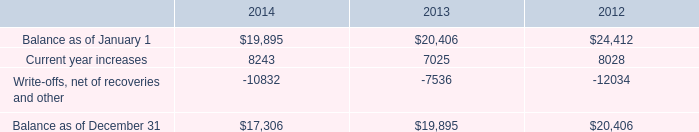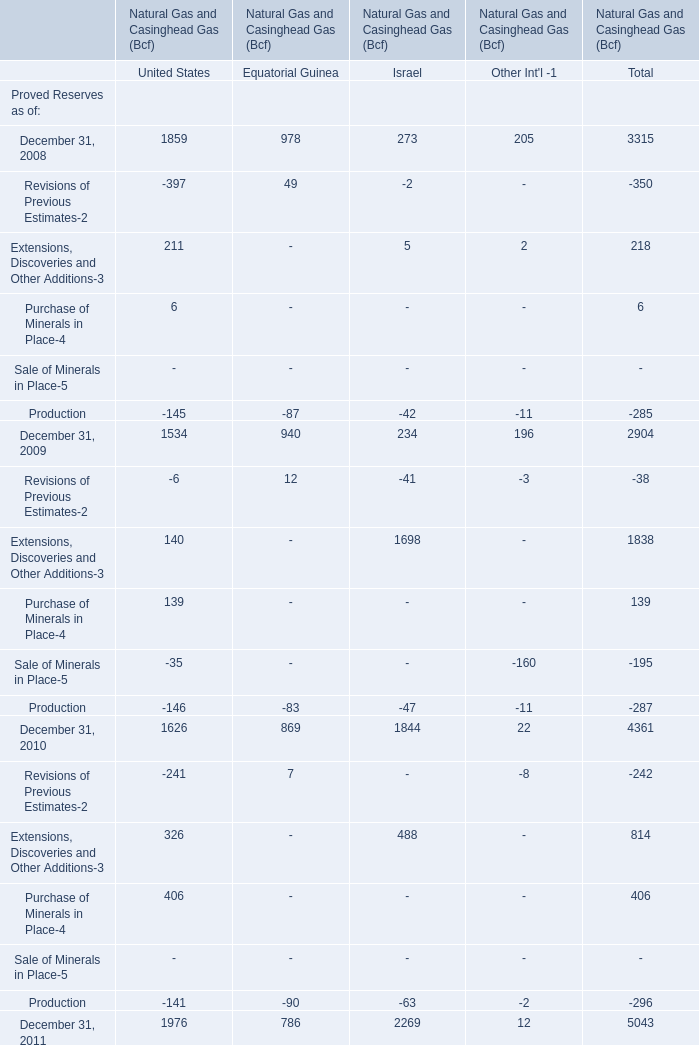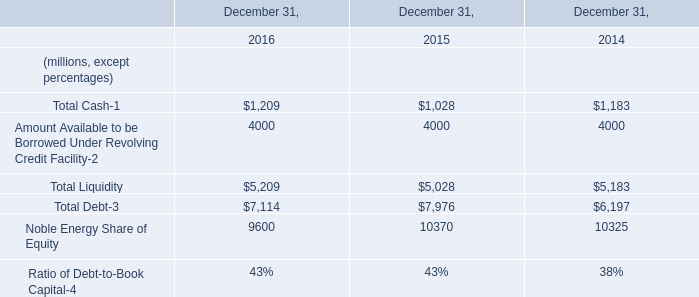for the four largest tenants , what is the average % ( % ) of current year revenues that each represents? 
Computations: (56 / 4)
Answer: 14.0. 